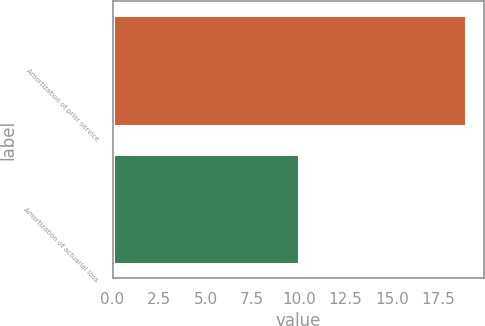Convert chart to OTSL. <chart><loc_0><loc_0><loc_500><loc_500><bar_chart><fcel>Amortization of prior service<fcel>Amortization of actuarial loss<nl><fcel>19<fcel>10<nl></chart> 